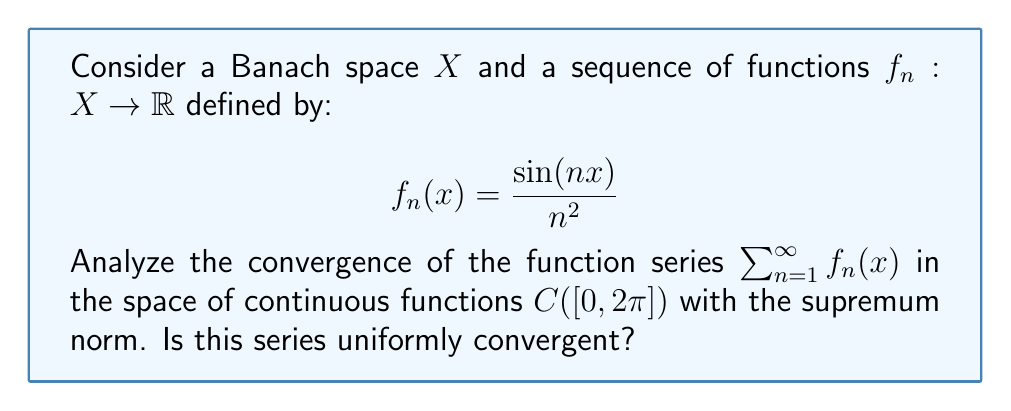What is the answer to this math problem? To analyze the convergence of this function series, we'll follow these steps:

1) First, we need to check if the series converges pointwise. For any fixed $x \in [0, 2\pi]$, we have:

   $$\left|\frac{\sin(nx)}{n^2}\right| \leq \frac{1}{n^2}$$

   This is because $|\sin(nx)| \leq 1$ for all $n$ and $x$.

2) The series $\sum_{n=1}^{\infty} \frac{1}{n^2}$ is a p-series with $p=2 > 1$, which is known to converge. Therefore, by the comparison test, our series converges pointwise for all $x \in [0, 2\pi]$.

3) To check for uniform convergence, we can use the Weierstrass M-test. We need to find a sequence of positive terms $M_n$ such that:

   $$|f_n(x)| \leq M_n \quad \text{for all } x \in [0, 2\pi] \text{ and } n \in \mathbb{N}$$

   and $\sum_{n=1}^{\infty} M_n$ converges.

4) We can choose $M_n = \frac{1}{n^2}$, as we saw in step 1 that this bound holds for all $x$.

5) We already know that $\sum_{n=1}^{\infty} \frac{1}{n^2}$ converges (it's equal to $\frac{\pi^2}{6}$).

6) Therefore, by the Weierstrass M-test, the series $\sum_{n=1}^{\infty} f_n(x)$ converges uniformly on $[0, 2\pi]$.

7) Since each $f_n$ is continuous on $[0, 2\pi]$ and the convergence is uniform, the sum function $f(x) = \sum_{n=1}^{\infty} f_n(x)$ is also continuous on $[0, 2\pi]$.

8) Thus, the series converges in the space $C([0, 2\pi])$ with the supremum norm.
Answer: The series $\sum_{n=1}^{\infty} f_n(x)$ converges uniformly in $C([0, 2\pi])$. 